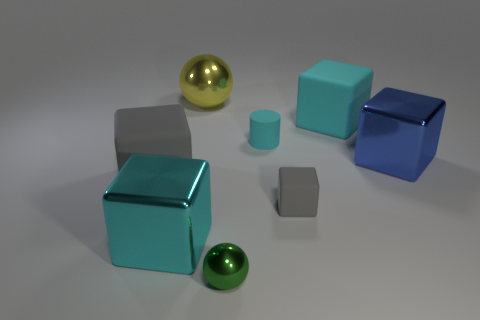Subtract all yellow blocks. Subtract all cyan cylinders. How many blocks are left? 5 Add 2 cyan metallic things. How many objects exist? 10 Subtract all cylinders. How many objects are left? 7 Add 2 small matte cubes. How many small matte cubes exist? 3 Subtract 1 yellow spheres. How many objects are left? 7 Subtract all small blue shiny objects. Subtract all cubes. How many objects are left? 3 Add 4 green metallic things. How many green metallic things are left? 5 